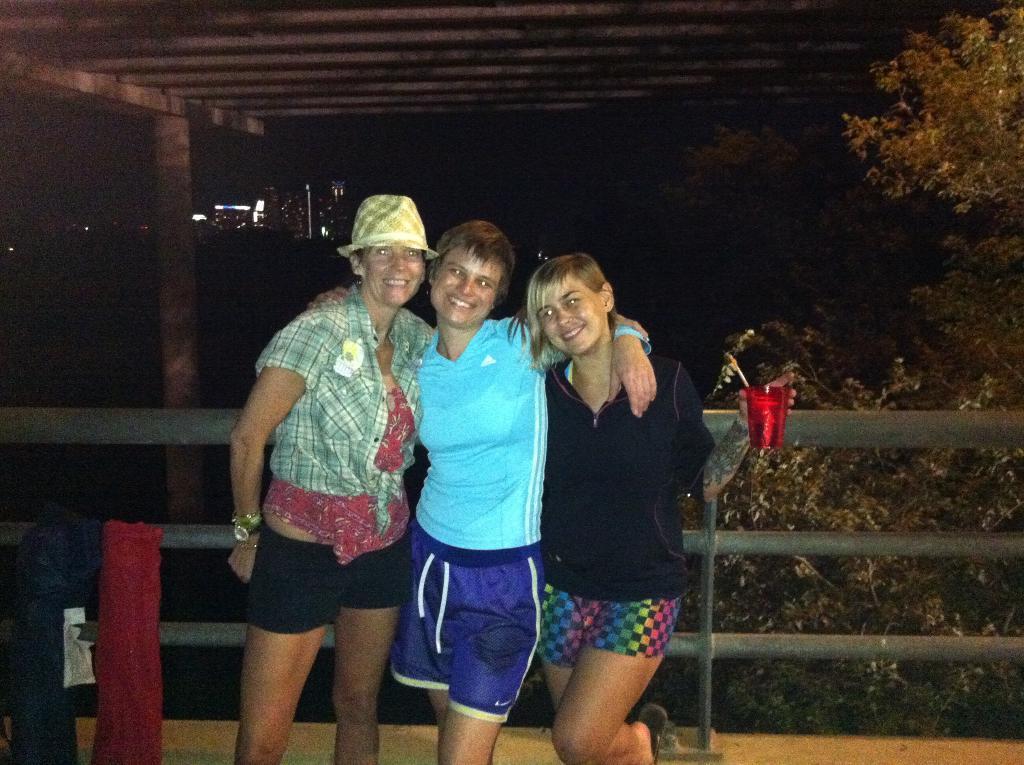How would you summarize this image in a sentence or two? In this image we can see three women standing beside the metal fence. In that a woman is holding a glass. On the left bottom we can see some folded mats on the floor. On the backside we can see a group of trees and a roof with a pillar. 